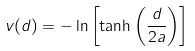Convert formula to latex. <formula><loc_0><loc_0><loc_500><loc_500>v ( d ) = - \ln \left [ \tanh \left ( \frac { d } { 2 a } \right ) \right ]</formula> 